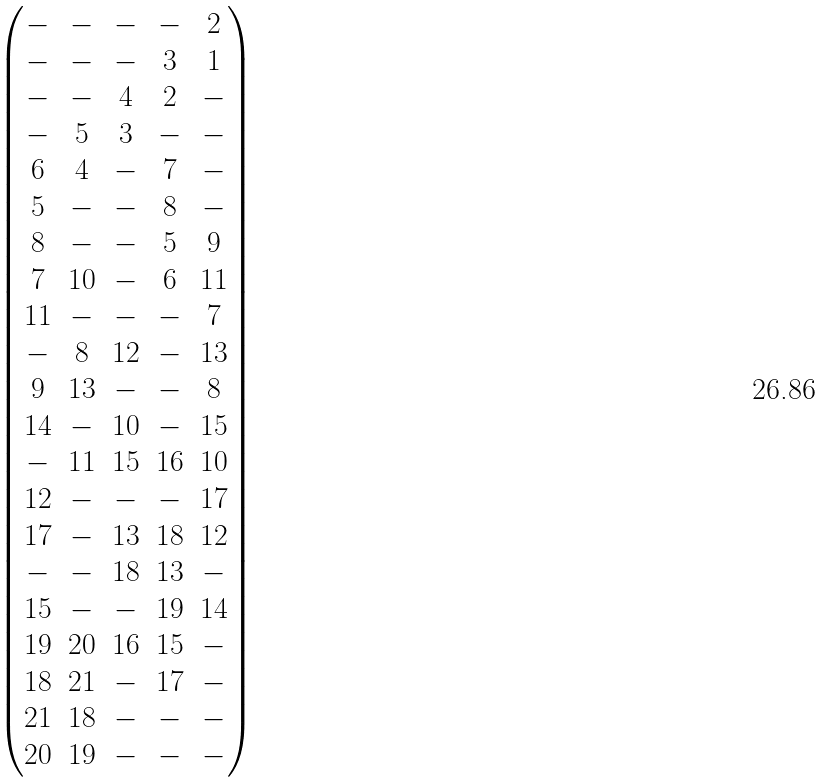<formula> <loc_0><loc_0><loc_500><loc_500>\begin{pmatrix} - & - & - & - & 2 \\ - & - & - & 3 & 1 \\ - & - & 4 & 2 & - \\ - & 5 & 3 & - & - \\ 6 & 4 & - & 7 & - \\ 5 & - & - & 8 & - \\ 8 & - & - & 5 & 9 \\ 7 & 1 0 & - & 6 & 1 1 \\ 1 1 & - & - & - & 7 \\ - & 8 & 1 2 & - & 1 3 \\ 9 & 1 3 & - & - & 8 \\ 1 4 & - & 1 0 & - & 1 5 \\ - & 1 1 & 1 5 & 1 6 & 1 0 \\ 1 2 & - & - & - & 1 7 \\ 1 7 & - & 1 3 & 1 8 & 1 2 \\ - & - & 1 8 & 1 3 & - \\ 1 5 & - & - & 1 9 & 1 4 \\ 1 9 & 2 0 & 1 6 & 1 5 & - \\ 1 8 & 2 1 & - & 1 7 & - \\ 2 1 & 1 8 & - & - & - \\ 2 0 & 1 9 & - & - & - \end{pmatrix}</formula> 